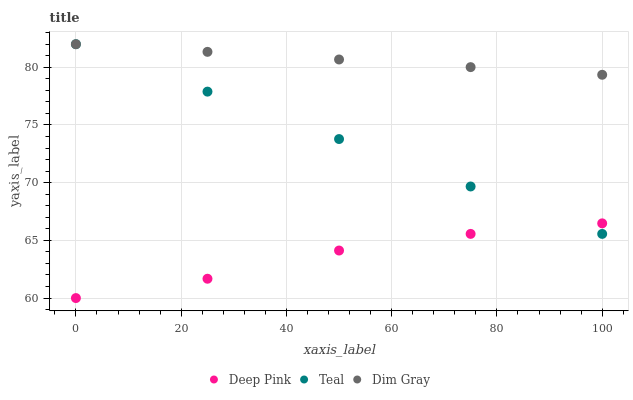Does Deep Pink have the minimum area under the curve?
Answer yes or no. Yes. Does Dim Gray have the maximum area under the curve?
Answer yes or no. Yes. Does Teal have the minimum area under the curve?
Answer yes or no. No. Does Teal have the maximum area under the curve?
Answer yes or no. No. Is Teal the smoothest?
Answer yes or no. Yes. Is Deep Pink the roughest?
Answer yes or no. Yes. Is Deep Pink the smoothest?
Answer yes or no. No. Is Teal the roughest?
Answer yes or no. No. Does Deep Pink have the lowest value?
Answer yes or no. Yes. Does Teal have the lowest value?
Answer yes or no. No. Does Teal have the highest value?
Answer yes or no. Yes. Does Deep Pink have the highest value?
Answer yes or no. No. Is Deep Pink less than Dim Gray?
Answer yes or no. Yes. Is Dim Gray greater than Deep Pink?
Answer yes or no. Yes. Does Deep Pink intersect Teal?
Answer yes or no. Yes. Is Deep Pink less than Teal?
Answer yes or no. No. Is Deep Pink greater than Teal?
Answer yes or no. No. Does Deep Pink intersect Dim Gray?
Answer yes or no. No. 